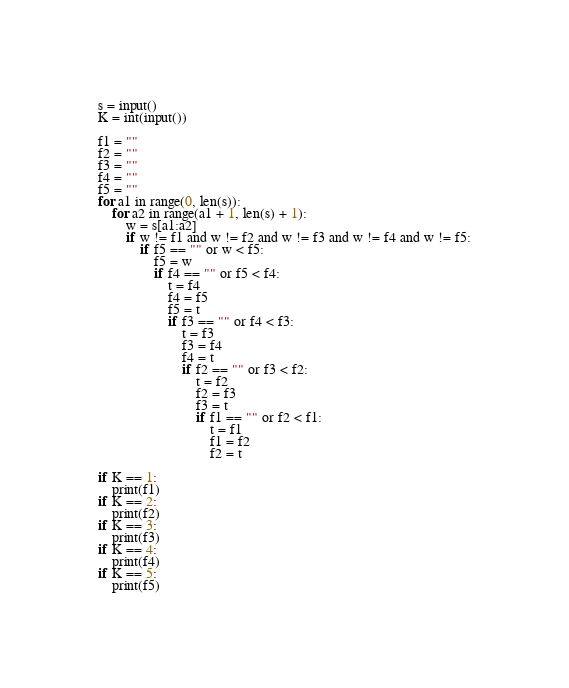Convert code to text. <code><loc_0><loc_0><loc_500><loc_500><_Python_>s = input()
K = int(input())

f1 = ""
f2 = ""
f3 = ""
f4 = ""
f5 = ""
for a1 in range(0, len(s)):
	for a2 in range(a1 + 1, len(s) + 1):
		w = s[a1:a2]
		if w != f1 and w != f2 and w != f3 and w != f4 and w != f5:
			if f5 == "" or w < f5:
				f5 = w
				if f4 == "" or f5 < f4:
					t = f4
					f4 = f5
					f5 = t
					if f3 == "" or f4 < f3:
						t = f3
						f3 = f4
						f4 = t
						if f2 == "" or f3 < f2:
							t = f2
							f2 = f3
							f3 = t
							if f1 == "" or f2 < f1:
								t = f1
								f1 = f2
								f2 = t

if K == 1:
	print(f1)
if K == 2:
	print(f2)
if K == 3:
	print(f3)
if K == 4:
	print(f4)
if K == 5:
	print(f5)</code> 